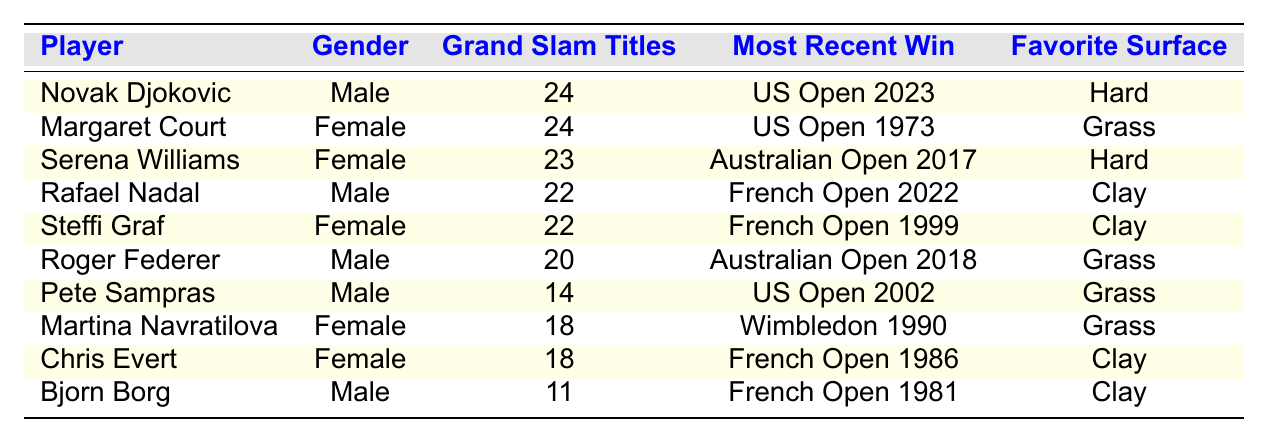What is the total number of Grand Slam titles won by male players in the table? There are four male players listed: Novak Djokovic with 24 titles, Rafael Nadal with 22 titles, Roger Federer with 20 titles, and Pete Sampras with 14 titles. Adding these gives 24 + 22 + 20 + 14 = 80 total titles won by male players.
Answer: 80 Who has the most Grand Slam titles among female players? In the table, Margaret Court has the highest number of Grand Slam titles with 24, which is shown as the maximum value for the female category.
Answer: Margaret Court What is the favorite surface of Rafael Nadal? The table explicitly lists Rafael Nadal's favorite surface as Clay. This information is directly available in the corresponding row of the table.
Answer: Clay Is it true that Bjorn Borg has more Grand Slam titles than Martina Navratilova? By comparing their respective Grand Slam titles, Bjorn Borg has 11 titles while Martina Navratilova has 18 titles. Since 11 is less than 18, the statement is false.
Answer: False How many Grand Slam titles do Serena Williams and Steffi Graf have combined? To find their combined total, add Serena Williams's 23 titles and Steffi Graf's 22 titles: 23 + 22 = 45. Thus, the combined total is 45 titles.
Answer: 45 Who is the only player on the list with exactly 20 Grand Slam titles? The table shows Roger Federer as the only player with exactly 20 Grand Slam titles listed under the corresponding column.
Answer: Roger Federer Which surface did Margaret Court win her most recent Grand Slam title on? The table states that Margaret Court's most recent win was at the US Open in 1973, and it also indicates her favorite surface is Grass. As such, she won her last title on the Grass surface.
Answer: Grass If we consider both genders, who won the most recent Grand Slam title? Looking at the column for "Most Recent Win," Novak Djokovic's most recent victory is listed as US Open 2023, which is the latest date mentioned among all entries.
Answer: Novak Djokovic What is the average number of Grand Slam titles across all players in the list? There are 10 players in total, and their Grand Slam titles sum to (24 + 24 + 23 + 22 + 22 + 20 + 14 + 18 + 18 + 11) =  206 titles. To find the average, divide this total by the number of players: 206 / 10 = 20.6.
Answer: 20.6 How many players have won more than 20 Grand Slam titles? According to the table, Novak Djokovic (24) and Margaret Court (24) are the only players with more than 20 titles. Thus, there are 2 players.
Answer: 2 